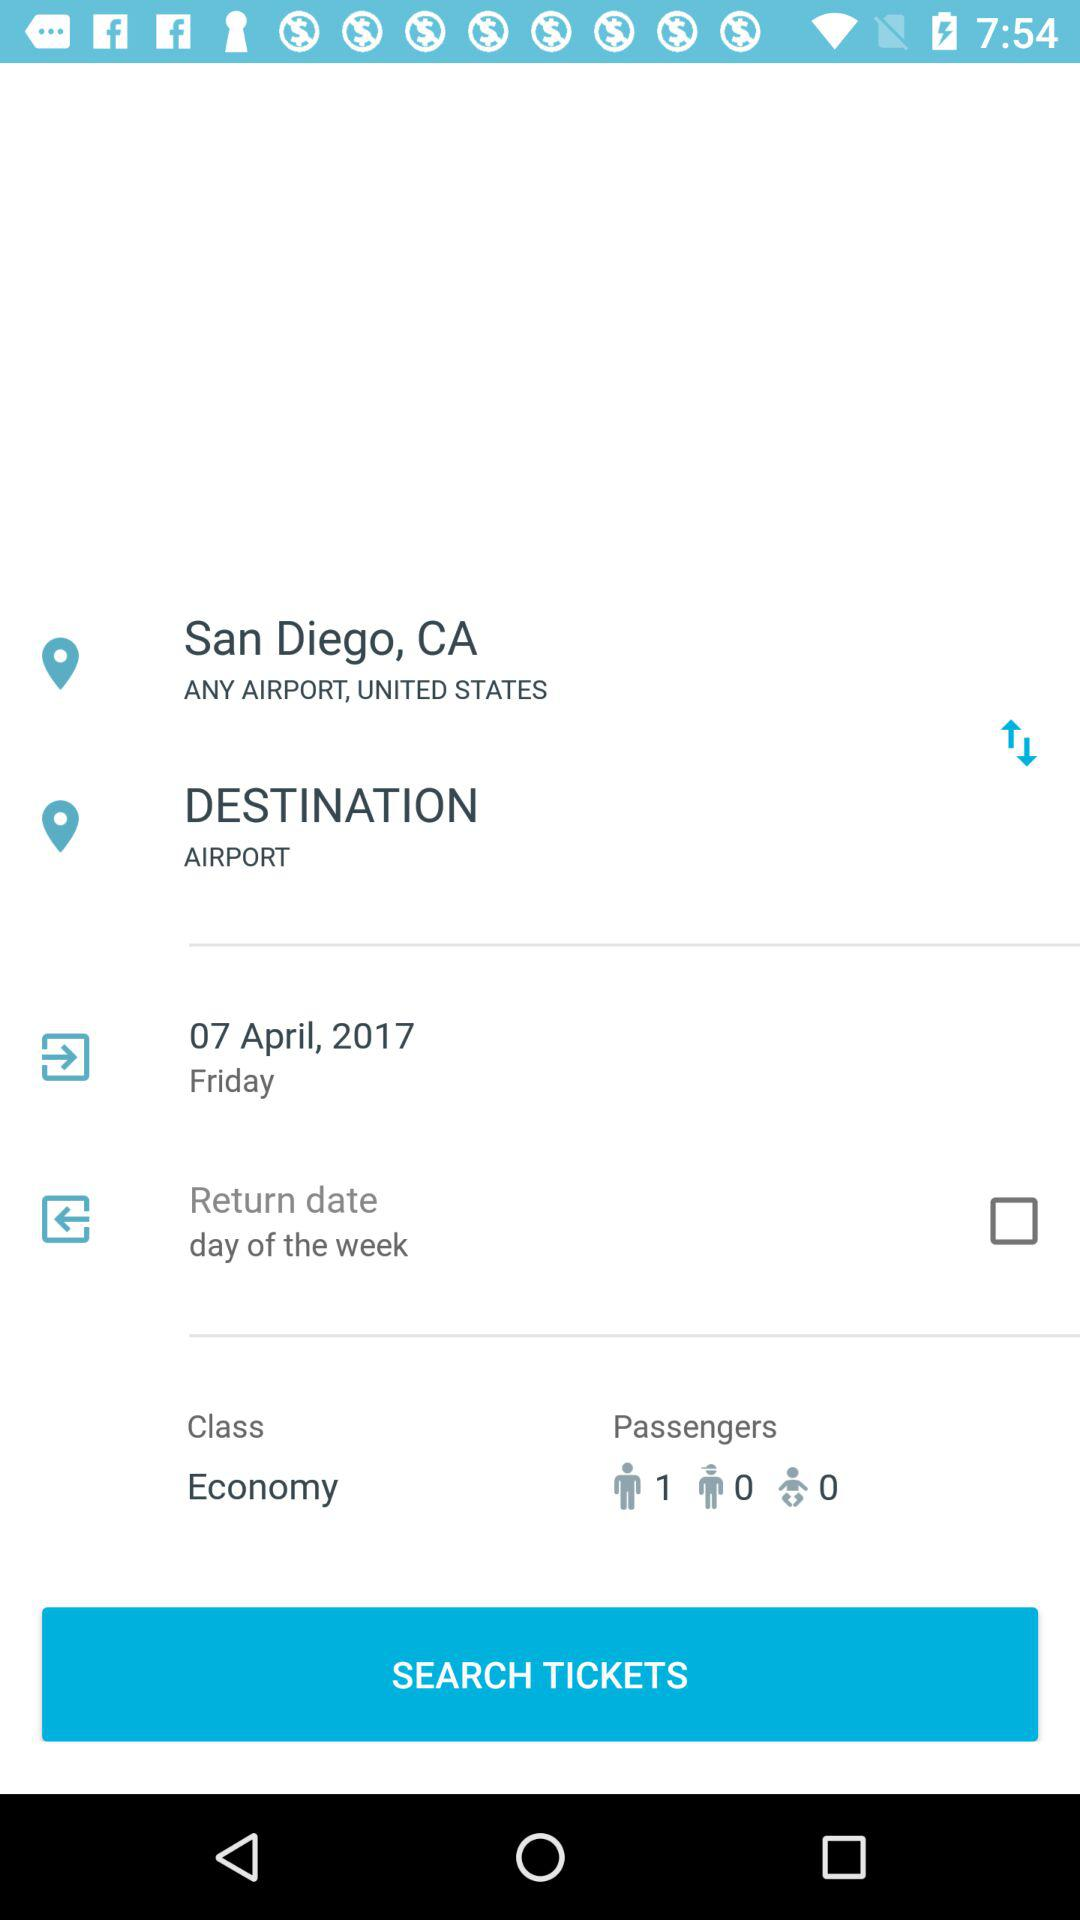How many passengers are going on this trip?
Answer the question using a single word or phrase. 1 